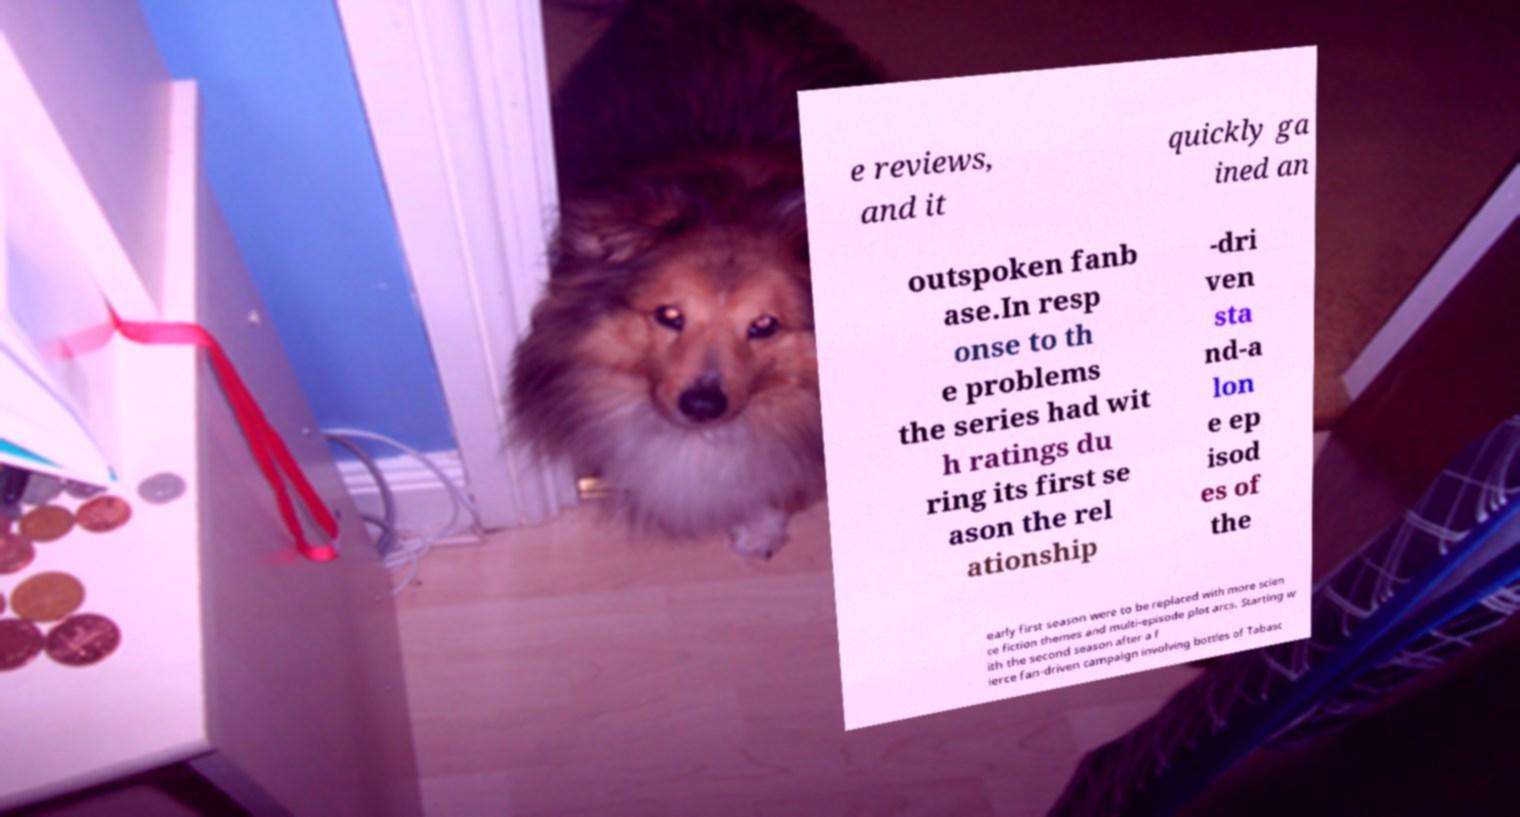Could you extract and type out the text from this image? e reviews, and it quickly ga ined an outspoken fanb ase.In resp onse to th e problems the series had wit h ratings du ring its first se ason the rel ationship -dri ven sta nd-a lon e ep isod es of the early first season were to be replaced with more scien ce fiction themes and multi-episode plot arcs. Starting w ith the second season after a f ierce fan-driven campaign involving bottles of Tabasc 